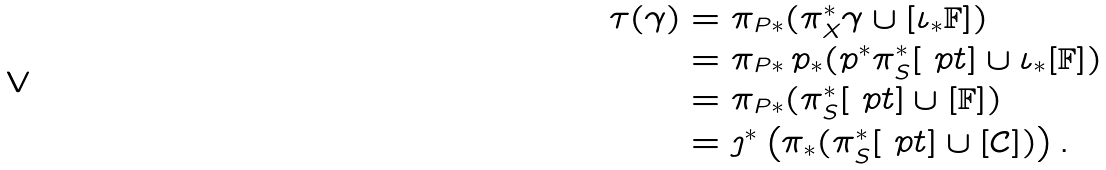Convert formula to latex. <formula><loc_0><loc_0><loc_500><loc_500>\tau ( \gamma ) & = \pi _ { P \ast } ( \pi _ { X } ^ { \ast } \gamma \cup [ \iota _ { * } \mathbb { F } ] ) \\ & = \pi _ { P \ast } \, p _ { \ast } ( p ^ { * } \pi _ { S } ^ { \ast } [ \ p t ] \cup \iota _ { * } [ \mathbb { F } ] ) \\ & = \pi _ { P \ast } ( \pi _ { S } ^ { \ast } [ \ p t ] \cup [ \mathbb { F } ] ) \\ & = \jmath ^ { * } \left ( \pi _ { \ast } ( \pi _ { S } ^ { \ast } [ \ p t ] \cup [ \mathcal { C } ] ) \right ) .</formula> 